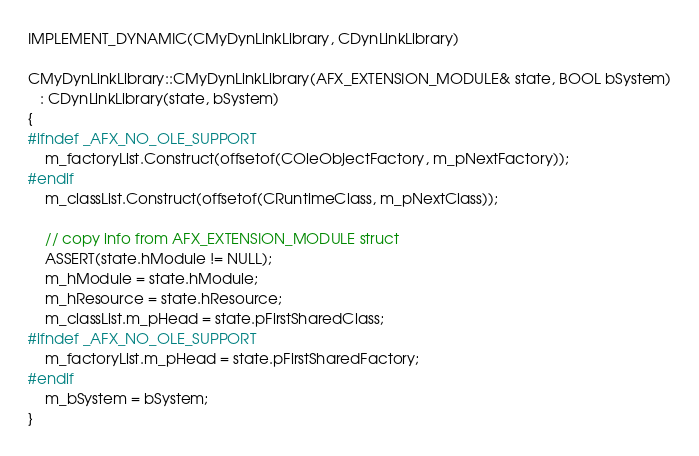<code> <loc_0><loc_0><loc_500><loc_500><_C++_>IMPLEMENT_DYNAMIC(CMyDynLinkLibrary, CDynLinkLibrary)

CMyDynLinkLibrary::CMyDynLinkLibrary(AFX_EXTENSION_MODULE& state, BOOL bSystem)
   : CDynLinkLibrary(state, bSystem)
{
#ifndef _AFX_NO_OLE_SUPPORT
	m_factoryList.Construct(offsetof(COleObjectFactory, m_pNextFactory));
#endif
	m_classList.Construct(offsetof(CRuntimeClass, m_pNextClass));

	// copy info from AFX_EXTENSION_MODULE struct
	ASSERT(state.hModule != NULL);
	m_hModule = state.hModule;
	m_hResource = state.hResource;
	m_classList.m_pHead = state.pFirstSharedClass;
#ifndef _AFX_NO_OLE_SUPPORT
	m_factoryList.m_pHead = state.pFirstSharedFactory;
#endif
	m_bSystem = bSystem;
}</code> 